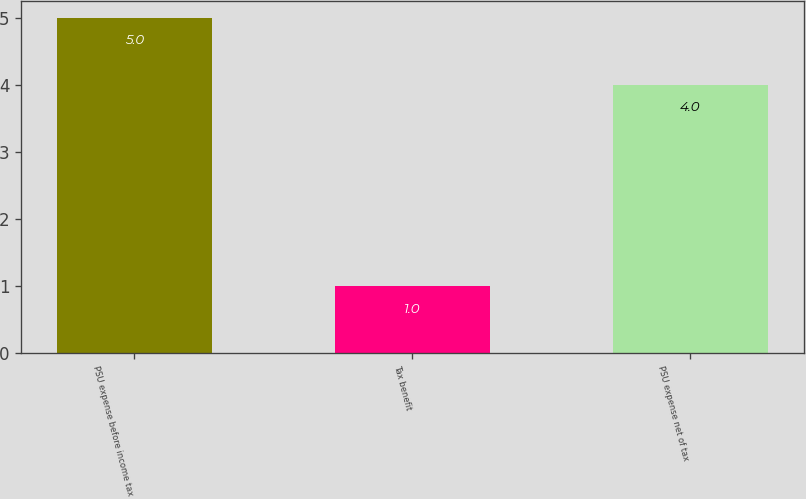Convert chart to OTSL. <chart><loc_0><loc_0><loc_500><loc_500><bar_chart><fcel>PSU expense before income tax<fcel>Tax benefit<fcel>PSU expense net of tax<nl><fcel>5<fcel>1<fcel>4<nl></chart> 